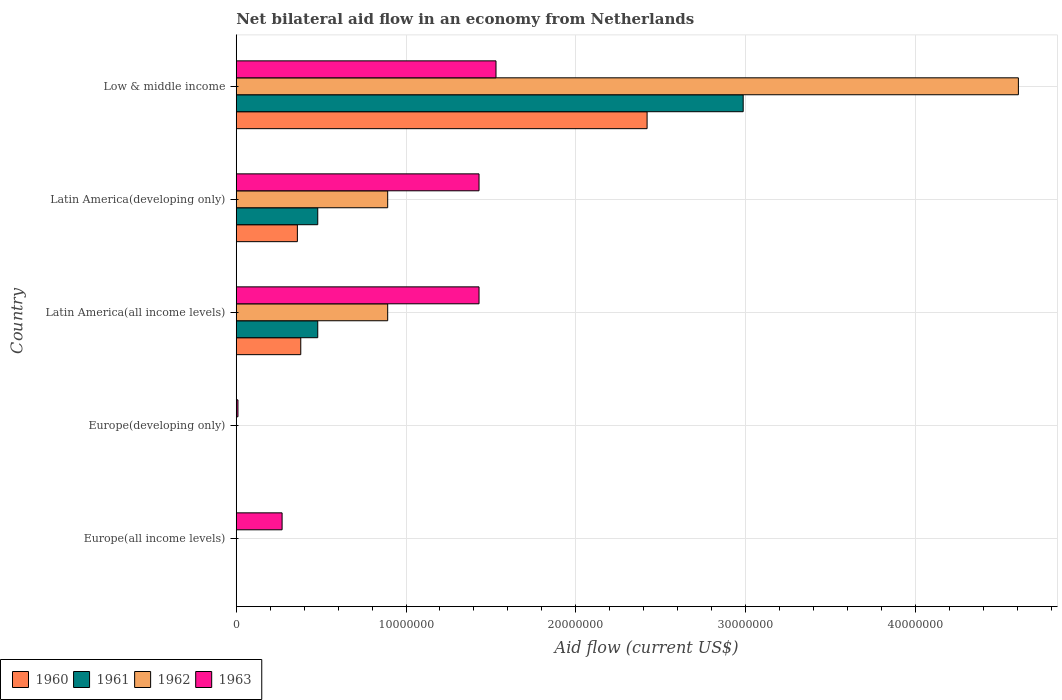How many different coloured bars are there?
Give a very brief answer. 4. Are the number of bars on each tick of the Y-axis equal?
Make the answer very short. No. How many bars are there on the 3rd tick from the top?
Make the answer very short. 4. How many bars are there on the 2nd tick from the bottom?
Give a very brief answer. 1. What is the label of the 5th group of bars from the top?
Ensure brevity in your answer.  Europe(all income levels). What is the net bilateral aid flow in 1963 in Latin America(developing only)?
Keep it short and to the point. 1.43e+07. Across all countries, what is the maximum net bilateral aid flow in 1960?
Provide a short and direct response. 2.42e+07. In which country was the net bilateral aid flow in 1962 maximum?
Offer a very short reply. Low & middle income. What is the total net bilateral aid flow in 1962 in the graph?
Your answer should be compact. 6.39e+07. What is the difference between the net bilateral aid flow in 1960 in Latin America(all income levels) and that in Low & middle income?
Provide a short and direct response. -2.04e+07. What is the difference between the net bilateral aid flow in 1963 in Latin America(developing only) and the net bilateral aid flow in 1962 in Europe(all income levels)?
Keep it short and to the point. 1.43e+07. What is the average net bilateral aid flow in 1960 per country?
Ensure brevity in your answer.  6.32e+06. What is the difference between the net bilateral aid flow in 1961 and net bilateral aid flow in 1963 in Latin America(developing only)?
Offer a very short reply. -9.50e+06. In how many countries, is the net bilateral aid flow in 1960 greater than 30000000 US$?
Your response must be concise. 0. What is the ratio of the net bilateral aid flow in 1963 in Latin America(developing only) to that in Low & middle income?
Ensure brevity in your answer.  0.93. Is the difference between the net bilateral aid flow in 1961 in Latin America(developing only) and Low & middle income greater than the difference between the net bilateral aid flow in 1963 in Latin America(developing only) and Low & middle income?
Make the answer very short. No. What is the difference between the highest and the second highest net bilateral aid flow in 1961?
Give a very brief answer. 2.51e+07. What is the difference between the highest and the lowest net bilateral aid flow in 1962?
Make the answer very short. 4.61e+07. In how many countries, is the net bilateral aid flow in 1961 greater than the average net bilateral aid flow in 1961 taken over all countries?
Your response must be concise. 1. Is it the case that in every country, the sum of the net bilateral aid flow in 1961 and net bilateral aid flow in 1963 is greater than the net bilateral aid flow in 1960?
Ensure brevity in your answer.  Yes. How many bars are there?
Your answer should be very brief. 14. Are all the bars in the graph horizontal?
Your response must be concise. Yes. How many countries are there in the graph?
Provide a short and direct response. 5. What is the difference between two consecutive major ticks on the X-axis?
Offer a very short reply. 1.00e+07. Does the graph contain any zero values?
Offer a very short reply. Yes. Does the graph contain grids?
Your response must be concise. Yes. How many legend labels are there?
Provide a short and direct response. 4. How are the legend labels stacked?
Your answer should be compact. Horizontal. What is the title of the graph?
Your response must be concise. Net bilateral aid flow in an economy from Netherlands. Does "1997" appear as one of the legend labels in the graph?
Ensure brevity in your answer.  No. What is the label or title of the X-axis?
Ensure brevity in your answer.  Aid flow (current US$). What is the label or title of the Y-axis?
Ensure brevity in your answer.  Country. What is the Aid flow (current US$) in 1960 in Europe(all income levels)?
Your answer should be very brief. 0. What is the Aid flow (current US$) in 1962 in Europe(all income levels)?
Your response must be concise. 0. What is the Aid flow (current US$) of 1963 in Europe(all income levels)?
Offer a very short reply. 2.70e+06. What is the Aid flow (current US$) of 1962 in Europe(developing only)?
Your answer should be very brief. 0. What is the Aid flow (current US$) of 1963 in Europe(developing only)?
Ensure brevity in your answer.  1.00e+05. What is the Aid flow (current US$) in 1960 in Latin America(all income levels)?
Provide a short and direct response. 3.80e+06. What is the Aid flow (current US$) of 1961 in Latin America(all income levels)?
Offer a terse response. 4.80e+06. What is the Aid flow (current US$) of 1962 in Latin America(all income levels)?
Keep it short and to the point. 8.92e+06. What is the Aid flow (current US$) of 1963 in Latin America(all income levels)?
Offer a terse response. 1.43e+07. What is the Aid flow (current US$) in 1960 in Latin America(developing only)?
Provide a short and direct response. 3.60e+06. What is the Aid flow (current US$) of 1961 in Latin America(developing only)?
Make the answer very short. 4.80e+06. What is the Aid flow (current US$) in 1962 in Latin America(developing only)?
Your response must be concise. 8.92e+06. What is the Aid flow (current US$) in 1963 in Latin America(developing only)?
Offer a very short reply. 1.43e+07. What is the Aid flow (current US$) of 1960 in Low & middle income?
Your answer should be very brief. 2.42e+07. What is the Aid flow (current US$) of 1961 in Low & middle income?
Your answer should be very brief. 2.99e+07. What is the Aid flow (current US$) in 1962 in Low & middle income?
Your answer should be compact. 4.61e+07. What is the Aid flow (current US$) of 1963 in Low & middle income?
Your response must be concise. 1.53e+07. Across all countries, what is the maximum Aid flow (current US$) in 1960?
Offer a terse response. 2.42e+07. Across all countries, what is the maximum Aid flow (current US$) of 1961?
Your response must be concise. 2.99e+07. Across all countries, what is the maximum Aid flow (current US$) of 1962?
Your response must be concise. 4.61e+07. Across all countries, what is the maximum Aid flow (current US$) of 1963?
Your answer should be compact. 1.53e+07. Across all countries, what is the minimum Aid flow (current US$) of 1962?
Offer a very short reply. 0. What is the total Aid flow (current US$) of 1960 in the graph?
Provide a short and direct response. 3.16e+07. What is the total Aid flow (current US$) in 1961 in the graph?
Provide a short and direct response. 3.95e+07. What is the total Aid flow (current US$) of 1962 in the graph?
Offer a very short reply. 6.39e+07. What is the total Aid flow (current US$) in 1963 in the graph?
Make the answer very short. 4.67e+07. What is the difference between the Aid flow (current US$) in 1963 in Europe(all income levels) and that in Europe(developing only)?
Your answer should be compact. 2.60e+06. What is the difference between the Aid flow (current US$) of 1963 in Europe(all income levels) and that in Latin America(all income levels)?
Your response must be concise. -1.16e+07. What is the difference between the Aid flow (current US$) in 1963 in Europe(all income levels) and that in Latin America(developing only)?
Ensure brevity in your answer.  -1.16e+07. What is the difference between the Aid flow (current US$) in 1963 in Europe(all income levels) and that in Low & middle income?
Provide a succinct answer. -1.26e+07. What is the difference between the Aid flow (current US$) of 1963 in Europe(developing only) and that in Latin America(all income levels)?
Provide a succinct answer. -1.42e+07. What is the difference between the Aid flow (current US$) in 1963 in Europe(developing only) and that in Latin America(developing only)?
Provide a succinct answer. -1.42e+07. What is the difference between the Aid flow (current US$) of 1963 in Europe(developing only) and that in Low & middle income?
Offer a terse response. -1.52e+07. What is the difference between the Aid flow (current US$) in 1960 in Latin America(all income levels) and that in Latin America(developing only)?
Your response must be concise. 2.00e+05. What is the difference between the Aid flow (current US$) in 1960 in Latin America(all income levels) and that in Low & middle income?
Provide a short and direct response. -2.04e+07. What is the difference between the Aid flow (current US$) in 1961 in Latin America(all income levels) and that in Low & middle income?
Your answer should be compact. -2.51e+07. What is the difference between the Aid flow (current US$) of 1962 in Latin America(all income levels) and that in Low & middle income?
Offer a very short reply. -3.72e+07. What is the difference between the Aid flow (current US$) in 1963 in Latin America(all income levels) and that in Low & middle income?
Ensure brevity in your answer.  -1.00e+06. What is the difference between the Aid flow (current US$) of 1960 in Latin America(developing only) and that in Low & middle income?
Offer a terse response. -2.06e+07. What is the difference between the Aid flow (current US$) in 1961 in Latin America(developing only) and that in Low & middle income?
Your response must be concise. -2.51e+07. What is the difference between the Aid flow (current US$) in 1962 in Latin America(developing only) and that in Low & middle income?
Offer a terse response. -3.72e+07. What is the difference between the Aid flow (current US$) in 1960 in Latin America(all income levels) and the Aid flow (current US$) in 1961 in Latin America(developing only)?
Offer a terse response. -1.00e+06. What is the difference between the Aid flow (current US$) of 1960 in Latin America(all income levels) and the Aid flow (current US$) of 1962 in Latin America(developing only)?
Offer a terse response. -5.12e+06. What is the difference between the Aid flow (current US$) in 1960 in Latin America(all income levels) and the Aid flow (current US$) in 1963 in Latin America(developing only)?
Your response must be concise. -1.05e+07. What is the difference between the Aid flow (current US$) of 1961 in Latin America(all income levels) and the Aid flow (current US$) of 1962 in Latin America(developing only)?
Give a very brief answer. -4.12e+06. What is the difference between the Aid flow (current US$) of 1961 in Latin America(all income levels) and the Aid flow (current US$) of 1963 in Latin America(developing only)?
Keep it short and to the point. -9.50e+06. What is the difference between the Aid flow (current US$) in 1962 in Latin America(all income levels) and the Aid flow (current US$) in 1963 in Latin America(developing only)?
Offer a very short reply. -5.38e+06. What is the difference between the Aid flow (current US$) of 1960 in Latin America(all income levels) and the Aid flow (current US$) of 1961 in Low & middle income?
Keep it short and to the point. -2.61e+07. What is the difference between the Aid flow (current US$) in 1960 in Latin America(all income levels) and the Aid flow (current US$) in 1962 in Low & middle income?
Make the answer very short. -4.23e+07. What is the difference between the Aid flow (current US$) in 1960 in Latin America(all income levels) and the Aid flow (current US$) in 1963 in Low & middle income?
Your response must be concise. -1.15e+07. What is the difference between the Aid flow (current US$) in 1961 in Latin America(all income levels) and the Aid flow (current US$) in 1962 in Low & middle income?
Your answer should be compact. -4.13e+07. What is the difference between the Aid flow (current US$) in 1961 in Latin America(all income levels) and the Aid flow (current US$) in 1963 in Low & middle income?
Your response must be concise. -1.05e+07. What is the difference between the Aid flow (current US$) in 1962 in Latin America(all income levels) and the Aid flow (current US$) in 1963 in Low & middle income?
Your answer should be compact. -6.38e+06. What is the difference between the Aid flow (current US$) in 1960 in Latin America(developing only) and the Aid flow (current US$) in 1961 in Low & middle income?
Your answer should be compact. -2.63e+07. What is the difference between the Aid flow (current US$) in 1960 in Latin America(developing only) and the Aid flow (current US$) in 1962 in Low & middle income?
Your response must be concise. -4.25e+07. What is the difference between the Aid flow (current US$) in 1960 in Latin America(developing only) and the Aid flow (current US$) in 1963 in Low & middle income?
Your response must be concise. -1.17e+07. What is the difference between the Aid flow (current US$) of 1961 in Latin America(developing only) and the Aid flow (current US$) of 1962 in Low & middle income?
Ensure brevity in your answer.  -4.13e+07. What is the difference between the Aid flow (current US$) of 1961 in Latin America(developing only) and the Aid flow (current US$) of 1963 in Low & middle income?
Make the answer very short. -1.05e+07. What is the difference between the Aid flow (current US$) of 1962 in Latin America(developing only) and the Aid flow (current US$) of 1963 in Low & middle income?
Offer a very short reply. -6.38e+06. What is the average Aid flow (current US$) of 1960 per country?
Provide a short and direct response. 6.32e+06. What is the average Aid flow (current US$) in 1961 per country?
Give a very brief answer. 7.89e+06. What is the average Aid flow (current US$) in 1962 per country?
Ensure brevity in your answer.  1.28e+07. What is the average Aid flow (current US$) of 1963 per country?
Give a very brief answer. 9.34e+06. What is the difference between the Aid flow (current US$) in 1960 and Aid flow (current US$) in 1962 in Latin America(all income levels)?
Provide a succinct answer. -5.12e+06. What is the difference between the Aid flow (current US$) of 1960 and Aid flow (current US$) of 1963 in Latin America(all income levels)?
Your response must be concise. -1.05e+07. What is the difference between the Aid flow (current US$) of 1961 and Aid flow (current US$) of 1962 in Latin America(all income levels)?
Ensure brevity in your answer.  -4.12e+06. What is the difference between the Aid flow (current US$) in 1961 and Aid flow (current US$) in 1963 in Latin America(all income levels)?
Your response must be concise. -9.50e+06. What is the difference between the Aid flow (current US$) in 1962 and Aid flow (current US$) in 1963 in Latin America(all income levels)?
Offer a terse response. -5.38e+06. What is the difference between the Aid flow (current US$) of 1960 and Aid flow (current US$) of 1961 in Latin America(developing only)?
Offer a very short reply. -1.20e+06. What is the difference between the Aid flow (current US$) of 1960 and Aid flow (current US$) of 1962 in Latin America(developing only)?
Your answer should be very brief. -5.32e+06. What is the difference between the Aid flow (current US$) of 1960 and Aid flow (current US$) of 1963 in Latin America(developing only)?
Keep it short and to the point. -1.07e+07. What is the difference between the Aid flow (current US$) of 1961 and Aid flow (current US$) of 1962 in Latin America(developing only)?
Your answer should be very brief. -4.12e+06. What is the difference between the Aid flow (current US$) in 1961 and Aid flow (current US$) in 1963 in Latin America(developing only)?
Keep it short and to the point. -9.50e+06. What is the difference between the Aid flow (current US$) of 1962 and Aid flow (current US$) of 1963 in Latin America(developing only)?
Your answer should be compact. -5.38e+06. What is the difference between the Aid flow (current US$) in 1960 and Aid flow (current US$) in 1961 in Low & middle income?
Give a very brief answer. -5.66e+06. What is the difference between the Aid flow (current US$) of 1960 and Aid flow (current US$) of 1962 in Low & middle income?
Provide a succinct answer. -2.19e+07. What is the difference between the Aid flow (current US$) of 1960 and Aid flow (current US$) of 1963 in Low & middle income?
Provide a succinct answer. 8.90e+06. What is the difference between the Aid flow (current US$) in 1961 and Aid flow (current US$) in 1962 in Low & middle income?
Keep it short and to the point. -1.62e+07. What is the difference between the Aid flow (current US$) of 1961 and Aid flow (current US$) of 1963 in Low & middle income?
Give a very brief answer. 1.46e+07. What is the difference between the Aid flow (current US$) of 1962 and Aid flow (current US$) of 1963 in Low & middle income?
Offer a very short reply. 3.08e+07. What is the ratio of the Aid flow (current US$) of 1963 in Europe(all income levels) to that in Latin America(all income levels)?
Your response must be concise. 0.19. What is the ratio of the Aid flow (current US$) in 1963 in Europe(all income levels) to that in Latin America(developing only)?
Provide a short and direct response. 0.19. What is the ratio of the Aid flow (current US$) in 1963 in Europe(all income levels) to that in Low & middle income?
Offer a very short reply. 0.18. What is the ratio of the Aid flow (current US$) of 1963 in Europe(developing only) to that in Latin America(all income levels)?
Your answer should be very brief. 0.01. What is the ratio of the Aid flow (current US$) in 1963 in Europe(developing only) to that in Latin America(developing only)?
Your answer should be very brief. 0.01. What is the ratio of the Aid flow (current US$) in 1963 in Europe(developing only) to that in Low & middle income?
Provide a short and direct response. 0.01. What is the ratio of the Aid flow (current US$) in 1960 in Latin America(all income levels) to that in Latin America(developing only)?
Ensure brevity in your answer.  1.06. What is the ratio of the Aid flow (current US$) in 1961 in Latin America(all income levels) to that in Latin America(developing only)?
Offer a very short reply. 1. What is the ratio of the Aid flow (current US$) in 1962 in Latin America(all income levels) to that in Latin America(developing only)?
Offer a terse response. 1. What is the ratio of the Aid flow (current US$) in 1960 in Latin America(all income levels) to that in Low & middle income?
Your answer should be very brief. 0.16. What is the ratio of the Aid flow (current US$) in 1961 in Latin America(all income levels) to that in Low & middle income?
Your response must be concise. 0.16. What is the ratio of the Aid flow (current US$) of 1962 in Latin America(all income levels) to that in Low & middle income?
Your answer should be compact. 0.19. What is the ratio of the Aid flow (current US$) of 1963 in Latin America(all income levels) to that in Low & middle income?
Your response must be concise. 0.93. What is the ratio of the Aid flow (current US$) in 1960 in Latin America(developing only) to that in Low & middle income?
Your response must be concise. 0.15. What is the ratio of the Aid flow (current US$) in 1961 in Latin America(developing only) to that in Low & middle income?
Ensure brevity in your answer.  0.16. What is the ratio of the Aid flow (current US$) in 1962 in Latin America(developing only) to that in Low & middle income?
Give a very brief answer. 0.19. What is the ratio of the Aid flow (current US$) in 1963 in Latin America(developing only) to that in Low & middle income?
Ensure brevity in your answer.  0.93. What is the difference between the highest and the second highest Aid flow (current US$) of 1960?
Keep it short and to the point. 2.04e+07. What is the difference between the highest and the second highest Aid flow (current US$) in 1961?
Make the answer very short. 2.51e+07. What is the difference between the highest and the second highest Aid flow (current US$) of 1962?
Your answer should be very brief. 3.72e+07. What is the difference between the highest and the second highest Aid flow (current US$) in 1963?
Keep it short and to the point. 1.00e+06. What is the difference between the highest and the lowest Aid flow (current US$) in 1960?
Your answer should be very brief. 2.42e+07. What is the difference between the highest and the lowest Aid flow (current US$) of 1961?
Provide a succinct answer. 2.99e+07. What is the difference between the highest and the lowest Aid flow (current US$) of 1962?
Your answer should be very brief. 4.61e+07. What is the difference between the highest and the lowest Aid flow (current US$) in 1963?
Keep it short and to the point. 1.52e+07. 